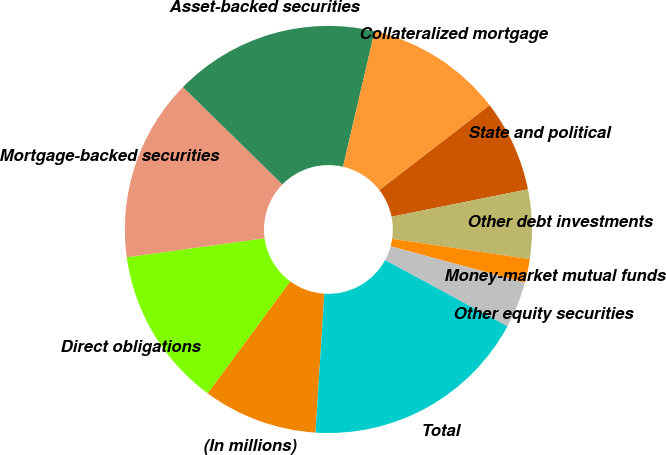Convert chart to OTSL. <chart><loc_0><loc_0><loc_500><loc_500><pie_chart><fcel>(In millions)<fcel>Direct obligations<fcel>Mortgage-backed securities<fcel>Asset-backed securities<fcel>Collateralized mortgage<fcel>State and political<fcel>Other debt investments<fcel>Money-market mutual funds<fcel>Other equity securities<fcel>Total<nl><fcel>9.1%<fcel>12.71%<fcel>14.51%<fcel>16.32%<fcel>10.9%<fcel>7.29%<fcel>5.49%<fcel>1.88%<fcel>3.68%<fcel>18.12%<nl></chart> 